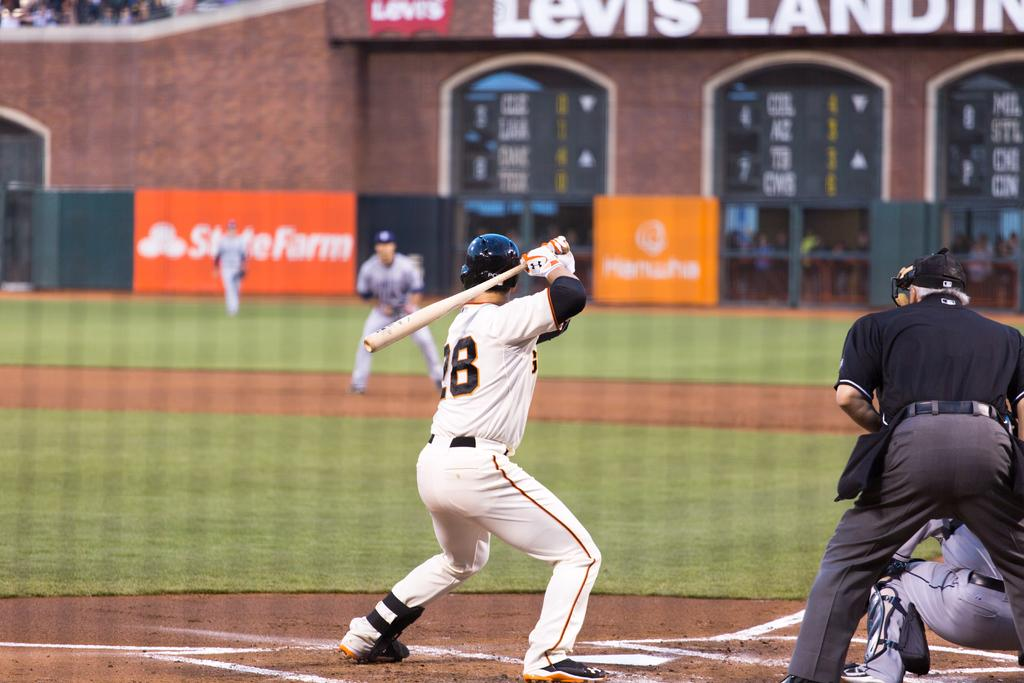<image>
Create a compact narrative representing the image presented. A baseball player is up to bat at Levis Landing in front of a State Farm sign. 